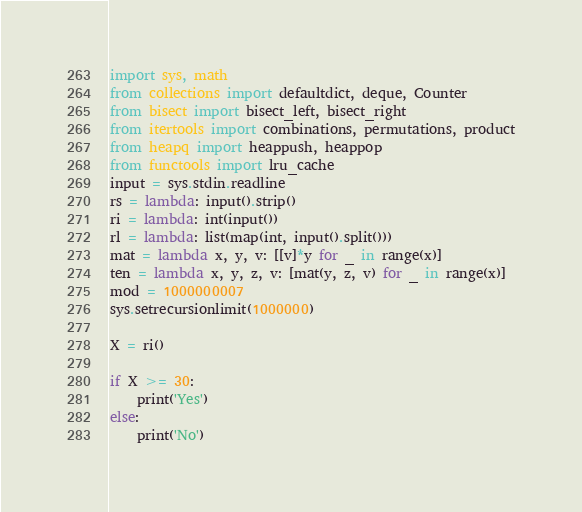<code> <loc_0><loc_0><loc_500><loc_500><_Python_>import sys, math
from collections import defaultdict, deque, Counter
from bisect import bisect_left, bisect_right
from itertools import combinations, permutations, product
from heapq import heappush, heappop
from functools import lru_cache
input = sys.stdin.readline
rs = lambda: input().strip()
ri = lambda: int(input())
rl = lambda: list(map(int, input().split()))
mat = lambda x, y, v: [[v]*y for _ in range(x)]
ten = lambda x, y, z, v: [mat(y, z, v) for _ in range(x)]
mod = 1000000007
sys.setrecursionlimit(1000000)

X = ri()

if X >= 30:
	print('Yes')
else:
	print('No')</code> 